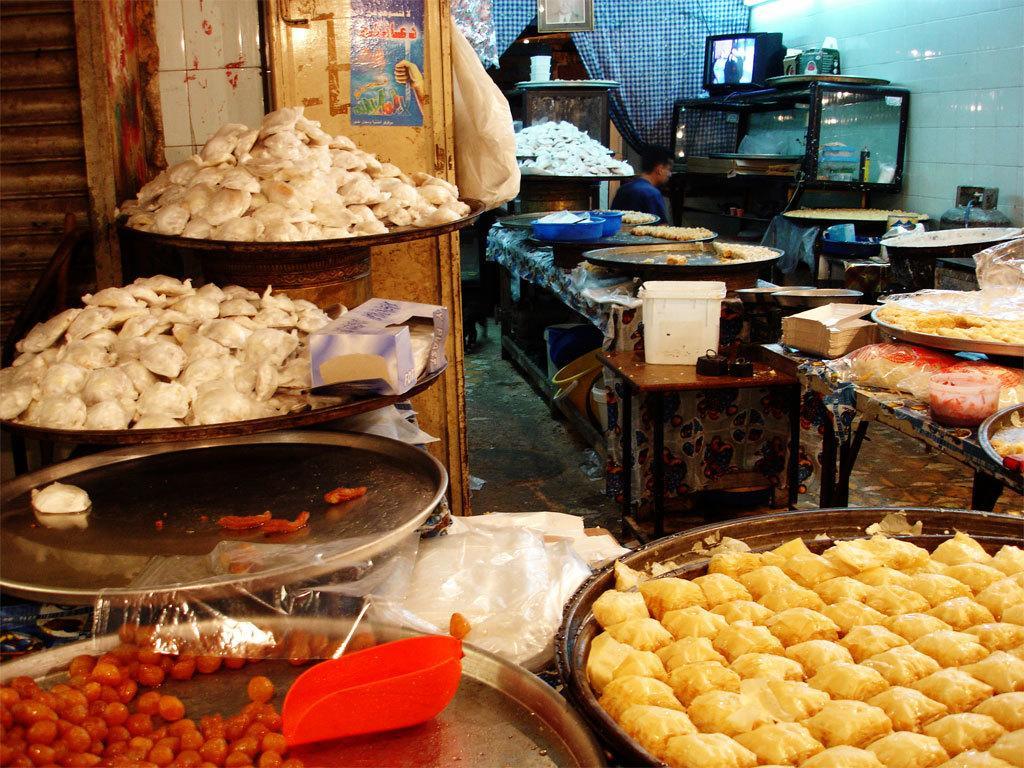Could you give a brief overview of what you see in this image? In this picture, it seems like food items on the plates in the foreground, there is a screen, a person, rack and other objects in the background. 